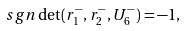<formula> <loc_0><loc_0><loc_500><loc_500>\ s g n \det ( r _ { 1 } ^ { - } , r _ { 2 } ^ { - } , U _ { 6 } ^ { - } ) = - 1 ,</formula> 